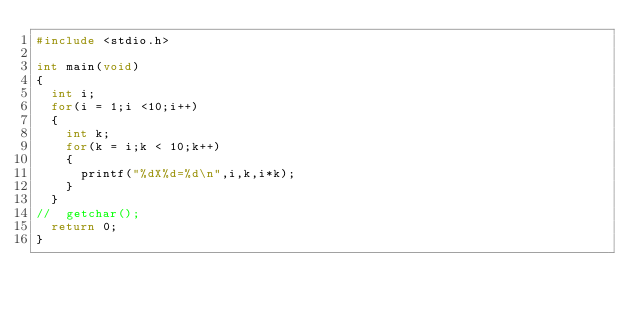<code> <loc_0><loc_0><loc_500><loc_500><_C_>#include <stdio.h>

int main(void)
{
	int i;
	for(i = 1;i <10;i++)
	{
		int k;
		for(k = i;k < 10;k++)
		{
			printf("%dX%d=%d\n",i,k,i*k);
		}
	}
//	getchar();
	return 0;
}</code> 